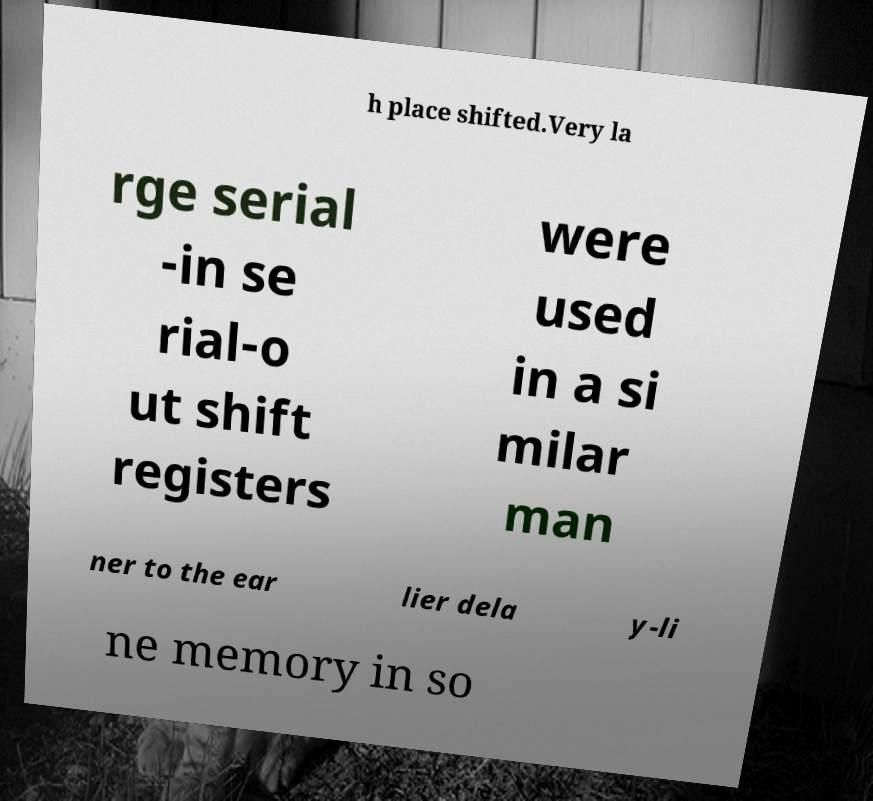Please read and relay the text visible in this image. What does it say? h place shifted.Very la rge serial -in se rial-o ut shift registers were used in a si milar man ner to the ear lier dela y-li ne memory in so 